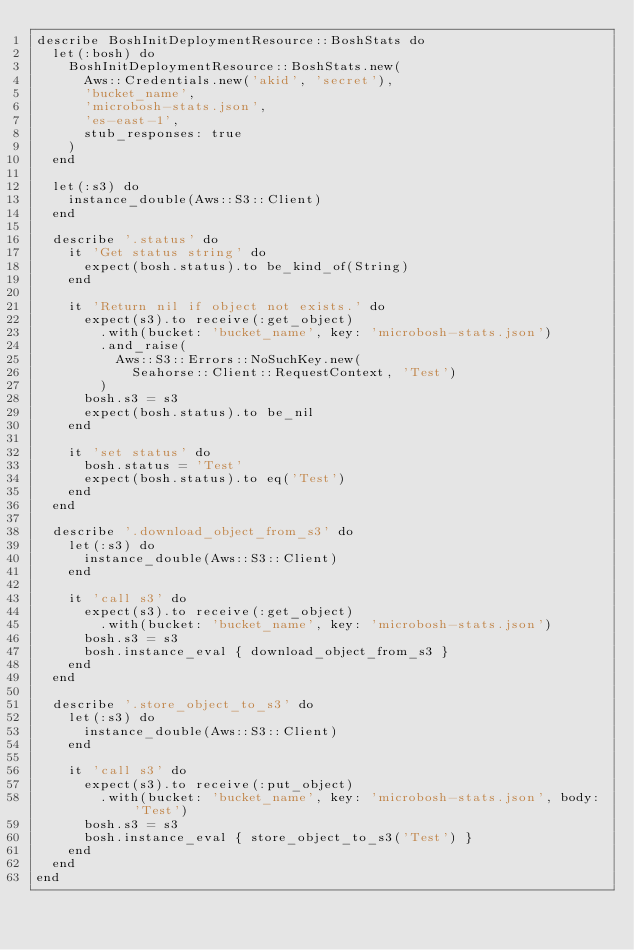Convert code to text. <code><loc_0><loc_0><loc_500><loc_500><_Ruby_>describe BoshInitDeploymentResource::BoshStats do
  let(:bosh) do
    BoshInitDeploymentResource::BoshStats.new(
      Aws::Credentials.new('akid', 'secret'),
      'bucket_name',
      'microbosh-stats.json',
      'es-east-1',
      stub_responses: true
    )
  end

  let(:s3) do
    instance_double(Aws::S3::Client)
  end

  describe '.status' do
    it 'Get status string' do
      expect(bosh.status).to be_kind_of(String)
    end

    it 'Return nil if object not exists.' do
      expect(s3).to receive(:get_object)
        .with(bucket: 'bucket_name', key: 'microbosh-stats.json')
        .and_raise(
          Aws::S3::Errors::NoSuchKey.new(
            Seahorse::Client::RequestContext, 'Test')
        )
      bosh.s3 = s3
      expect(bosh.status).to be_nil
    end

    it 'set status' do
      bosh.status = 'Test'
      expect(bosh.status).to eq('Test')
    end
  end

  describe '.download_object_from_s3' do
    let(:s3) do
      instance_double(Aws::S3::Client)
    end

    it 'call s3' do
      expect(s3).to receive(:get_object)
        .with(bucket: 'bucket_name', key: 'microbosh-stats.json')
      bosh.s3 = s3
      bosh.instance_eval { download_object_from_s3 }
    end
  end

  describe '.store_object_to_s3' do
    let(:s3) do
      instance_double(Aws::S3::Client)
    end

    it 'call s3' do
      expect(s3).to receive(:put_object)
        .with(bucket: 'bucket_name', key: 'microbosh-stats.json', body: 'Test')
      bosh.s3 = s3
      bosh.instance_eval { store_object_to_s3('Test') }
    end
  end
end
</code> 